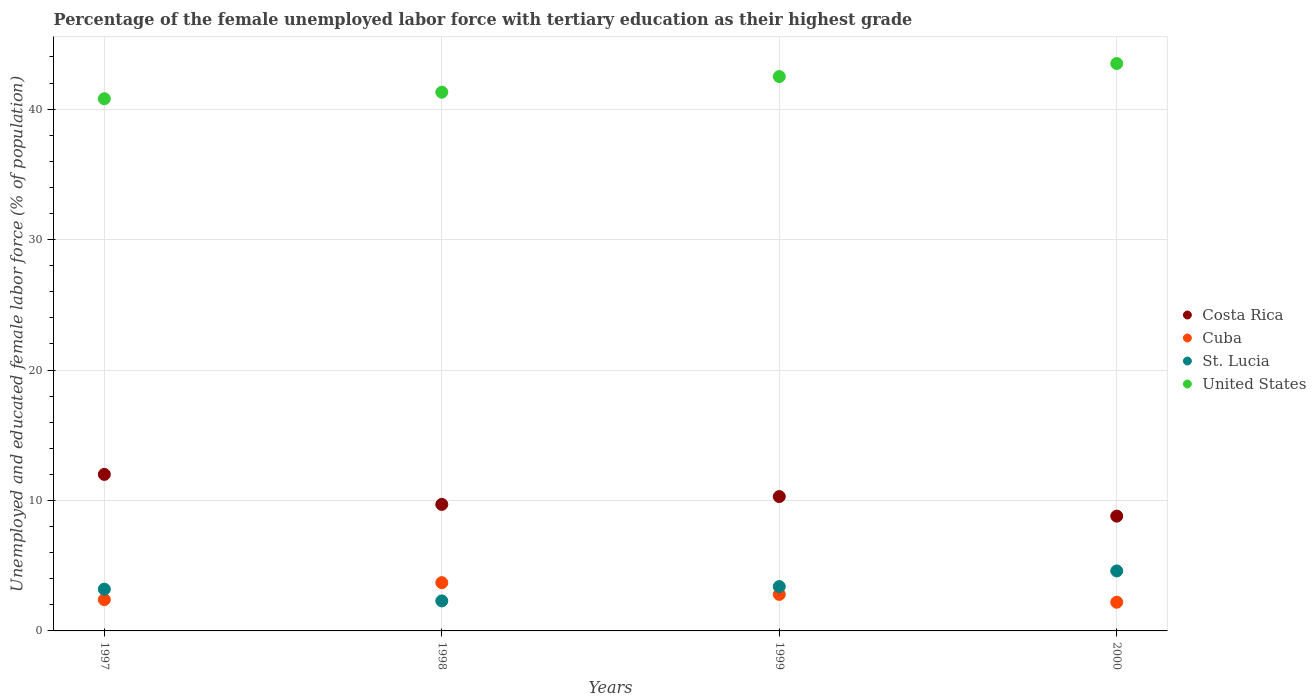What is the percentage of the unemployed female labor force with tertiary education in United States in 2000?
Offer a very short reply. 43.5. Across all years, what is the maximum percentage of the unemployed female labor force with tertiary education in Costa Rica?
Make the answer very short. 12. Across all years, what is the minimum percentage of the unemployed female labor force with tertiary education in Cuba?
Offer a very short reply. 2.2. In which year was the percentage of the unemployed female labor force with tertiary education in St. Lucia minimum?
Offer a terse response. 1998. What is the total percentage of the unemployed female labor force with tertiary education in Cuba in the graph?
Your answer should be very brief. 11.1. What is the difference between the percentage of the unemployed female labor force with tertiary education in United States in 1997 and that in 1999?
Provide a short and direct response. -1.7. What is the difference between the percentage of the unemployed female labor force with tertiary education in Cuba in 1997 and the percentage of the unemployed female labor force with tertiary education in United States in 2000?
Provide a succinct answer. -41.1. What is the average percentage of the unemployed female labor force with tertiary education in St. Lucia per year?
Provide a succinct answer. 3.38. In the year 1999, what is the difference between the percentage of the unemployed female labor force with tertiary education in Cuba and percentage of the unemployed female labor force with tertiary education in Costa Rica?
Provide a short and direct response. -7.5. In how many years, is the percentage of the unemployed female labor force with tertiary education in Costa Rica greater than 10 %?
Make the answer very short. 2. What is the ratio of the percentage of the unemployed female labor force with tertiary education in United States in 1998 to that in 1999?
Keep it short and to the point. 0.97. Is the percentage of the unemployed female labor force with tertiary education in Cuba in 1997 less than that in 2000?
Provide a succinct answer. No. What is the difference between the highest and the lowest percentage of the unemployed female labor force with tertiary education in St. Lucia?
Provide a succinct answer. 2.3. In how many years, is the percentage of the unemployed female labor force with tertiary education in St. Lucia greater than the average percentage of the unemployed female labor force with tertiary education in St. Lucia taken over all years?
Ensure brevity in your answer.  2. Is the sum of the percentage of the unemployed female labor force with tertiary education in Cuba in 1998 and 2000 greater than the maximum percentage of the unemployed female labor force with tertiary education in St. Lucia across all years?
Offer a very short reply. Yes. Is it the case that in every year, the sum of the percentage of the unemployed female labor force with tertiary education in Costa Rica and percentage of the unemployed female labor force with tertiary education in St. Lucia  is greater than the percentage of the unemployed female labor force with tertiary education in United States?
Provide a short and direct response. No. Is the percentage of the unemployed female labor force with tertiary education in United States strictly greater than the percentage of the unemployed female labor force with tertiary education in Cuba over the years?
Make the answer very short. Yes. Is the percentage of the unemployed female labor force with tertiary education in United States strictly less than the percentage of the unemployed female labor force with tertiary education in St. Lucia over the years?
Ensure brevity in your answer.  No. Are the values on the major ticks of Y-axis written in scientific E-notation?
Ensure brevity in your answer.  No. Does the graph contain grids?
Make the answer very short. Yes. What is the title of the graph?
Offer a very short reply. Percentage of the female unemployed labor force with tertiary education as their highest grade. What is the label or title of the Y-axis?
Ensure brevity in your answer.  Unemployed and educated female labor force (% of population). What is the Unemployed and educated female labor force (% of population) in Costa Rica in 1997?
Give a very brief answer. 12. What is the Unemployed and educated female labor force (% of population) of Cuba in 1997?
Keep it short and to the point. 2.4. What is the Unemployed and educated female labor force (% of population) in St. Lucia in 1997?
Make the answer very short. 3.2. What is the Unemployed and educated female labor force (% of population) of United States in 1997?
Keep it short and to the point. 40.8. What is the Unemployed and educated female labor force (% of population) of Costa Rica in 1998?
Make the answer very short. 9.7. What is the Unemployed and educated female labor force (% of population) in Cuba in 1998?
Ensure brevity in your answer.  3.7. What is the Unemployed and educated female labor force (% of population) in St. Lucia in 1998?
Provide a succinct answer. 2.3. What is the Unemployed and educated female labor force (% of population) in United States in 1998?
Ensure brevity in your answer.  41.3. What is the Unemployed and educated female labor force (% of population) in Costa Rica in 1999?
Offer a terse response. 10.3. What is the Unemployed and educated female labor force (% of population) of Cuba in 1999?
Ensure brevity in your answer.  2.8. What is the Unemployed and educated female labor force (% of population) of St. Lucia in 1999?
Offer a terse response. 3.4. What is the Unemployed and educated female labor force (% of population) in United States in 1999?
Keep it short and to the point. 42.5. What is the Unemployed and educated female labor force (% of population) in Costa Rica in 2000?
Provide a succinct answer. 8.8. What is the Unemployed and educated female labor force (% of population) in Cuba in 2000?
Your answer should be very brief. 2.2. What is the Unemployed and educated female labor force (% of population) in St. Lucia in 2000?
Ensure brevity in your answer.  4.6. What is the Unemployed and educated female labor force (% of population) of United States in 2000?
Ensure brevity in your answer.  43.5. Across all years, what is the maximum Unemployed and educated female labor force (% of population) of Cuba?
Give a very brief answer. 3.7. Across all years, what is the maximum Unemployed and educated female labor force (% of population) in St. Lucia?
Ensure brevity in your answer.  4.6. Across all years, what is the maximum Unemployed and educated female labor force (% of population) of United States?
Offer a terse response. 43.5. Across all years, what is the minimum Unemployed and educated female labor force (% of population) of Costa Rica?
Provide a succinct answer. 8.8. Across all years, what is the minimum Unemployed and educated female labor force (% of population) in Cuba?
Make the answer very short. 2.2. Across all years, what is the minimum Unemployed and educated female labor force (% of population) of St. Lucia?
Give a very brief answer. 2.3. Across all years, what is the minimum Unemployed and educated female labor force (% of population) in United States?
Offer a very short reply. 40.8. What is the total Unemployed and educated female labor force (% of population) in Costa Rica in the graph?
Offer a very short reply. 40.8. What is the total Unemployed and educated female labor force (% of population) in St. Lucia in the graph?
Your answer should be very brief. 13.5. What is the total Unemployed and educated female labor force (% of population) in United States in the graph?
Keep it short and to the point. 168.1. What is the difference between the Unemployed and educated female labor force (% of population) of Cuba in 1997 and that in 1998?
Offer a terse response. -1.3. What is the difference between the Unemployed and educated female labor force (% of population) of United States in 1997 and that in 1998?
Your response must be concise. -0.5. What is the difference between the Unemployed and educated female labor force (% of population) of United States in 1997 and that in 1999?
Make the answer very short. -1.7. What is the difference between the Unemployed and educated female labor force (% of population) of St. Lucia in 1997 and that in 2000?
Provide a succinct answer. -1.4. What is the difference between the Unemployed and educated female labor force (% of population) in United States in 1997 and that in 2000?
Your answer should be very brief. -2.7. What is the difference between the Unemployed and educated female labor force (% of population) in St. Lucia in 1998 and that in 1999?
Offer a very short reply. -1.1. What is the difference between the Unemployed and educated female labor force (% of population) in Costa Rica in 1998 and that in 2000?
Provide a short and direct response. 0.9. What is the difference between the Unemployed and educated female labor force (% of population) of St. Lucia in 1998 and that in 2000?
Offer a very short reply. -2.3. What is the difference between the Unemployed and educated female labor force (% of population) of United States in 1999 and that in 2000?
Make the answer very short. -1. What is the difference between the Unemployed and educated female labor force (% of population) of Costa Rica in 1997 and the Unemployed and educated female labor force (% of population) of Cuba in 1998?
Provide a short and direct response. 8.3. What is the difference between the Unemployed and educated female labor force (% of population) of Costa Rica in 1997 and the Unemployed and educated female labor force (% of population) of St. Lucia in 1998?
Make the answer very short. 9.7. What is the difference between the Unemployed and educated female labor force (% of population) in Costa Rica in 1997 and the Unemployed and educated female labor force (% of population) in United States in 1998?
Make the answer very short. -29.3. What is the difference between the Unemployed and educated female labor force (% of population) in Cuba in 1997 and the Unemployed and educated female labor force (% of population) in United States in 1998?
Your response must be concise. -38.9. What is the difference between the Unemployed and educated female labor force (% of population) in St. Lucia in 1997 and the Unemployed and educated female labor force (% of population) in United States in 1998?
Provide a short and direct response. -38.1. What is the difference between the Unemployed and educated female labor force (% of population) in Costa Rica in 1997 and the Unemployed and educated female labor force (% of population) in Cuba in 1999?
Provide a succinct answer. 9.2. What is the difference between the Unemployed and educated female labor force (% of population) of Costa Rica in 1997 and the Unemployed and educated female labor force (% of population) of United States in 1999?
Make the answer very short. -30.5. What is the difference between the Unemployed and educated female labor force (% of population) of Cuba in 1997 and the Unemployed and educated female labor force (% of population) of United States in 1999?
Keep it short and to the point. -40.1. What is the difference between the Unemployed and educated female labor force (% of population) of St. Lucia in 1997 and the Unemployed and educated female labor force (% of population) of United States in 1999?
Make the answer very short. -39.3. What is the difference between the Unemployed and educated female labor force (% of population) in Costa Rica in 1997 and the Unemployed and educated female labor force (% of population) in Cuba in 2000?
Offer a very short reply. 9.8. What is the difference between the Unemployed and educated female labor force (% of population) of Costa Rica in 1997 and the Unemployed and educated female labor force (% of population) of United States in 2000?
Provide a short and direct response. -31.5. What is the difference between the Unemployed and educated female labor force (% of population) of Cuba in 1997 and the Unemployed and educated female labor force (% of population) of United States in 2000?
Your response must be concise. -41.1. What is the difference between the Unemployed and educated female labor force (% of population) of St. Lucia in 1997 and the Unemployed and educated female labor force (% of population) of United States in 2000?
Keep it short and to the point. -40.3. What is the difference between the Unemployed and educated female labor force (% of population) of Costa Rica in 1998 and the Unemployed and educated female labor force (% of population) of Cuba in 1999?
Ensure brevity in your answer.  6.9. What is the difference between the Unemployed and educated female labor force (% of population) in Costa Rica in 1998 and the Unemployed and educated female labor force (% of population) in United States in 1999?
Provide a short and direct response. -32.8. What is the difference between the Unemployed and educated female labor force (% of population) in Cuba in 1998 and the Unemployed and educated female labor force (% of population) in St. Lucia in 1999?
Provide a short and direct response. 0.3. What is the difference between the Unemployed and educated female labor force (% of population) in Cuba in 1998 and the Unemployed and educated female labor force (% of population) in United States in 1999?
Your response must be concise. -38.8. What is the difference between the Unemployed and educated female labor force (% of population) in St. Lucia in 1998 and the Unemployed and educated female labor force (% of population) in United States in 1999?
Provide a short and direct response. -40.2. What is the difference between the Unemployed and educated female labor force (% of population) of Costa Rica in 1998 and the Unemployed and educated female labor force (% of population) of Cuba in 2000?
Give a very brief answer. 7.5. What is the difference between the Unemployed and educated female labor force (% of population) in Costa Rica in 1998 and the Unemployed and educated female labor force (% of population) in United States in 2000?
Provide a succinct answer. -33.8. What is the difference between the Unemployed and educated female labor force (% of population) in Cuba in 1998 and the Unemployed and educated female labor force (% of population) in St. Lucia in 2000?
Your response must be concise. -0.9. What is the difference between the Unemployed and educated female labor force (% of population) in Cuba in 1998 and the Unemployed and educated female labor force (% of population) in United States in 2000?
Keep it short and to the point. -39.8. What is the difference between the Unemployed and educated female labor force (% of population) of St. Lucia in 1998 and the Unemployed and educated female labor force (% of population) of United States in 2000?
Offer a very short reply. -41.2. What is the difference between the Unemployed and educated female labor force (% of population) of Costa Rica in 1999 and the Unemployed and educated female labor force (% of population) of Cuba in 2000?
Your answer should be compact. 8.1. What is the difference between the Unemployed and educated female labor force (% of population) of Costa Rica in 1999 and the Unemployed and educated female labor force (% of population) of St. Lucia in 2000?
Give a very brief answer. 5.7. What is the difference between the Unemployed and educated female labor force (% of population) of Costa Rica in 1999 and the Unemployed and educated female labor force (% of population) of United States in 2000?
Provide a short and direct response. -33.2. What is the difference between the Unemployed and educated female labor force (% of population) of Cuba in 1999 and the Unemployed and educated female labor force (% of population) of St. Lucia in 2000?
Offer a terse response. -1.8. What is the difference between the Unemployed and educated female labor force (% of population) of Cuba in 1999 and the Unemployed and educated female labor force (% of population) of United States in 2000?
Offer a terse response. -40.7. What is the difference between the Unemployed and educated female labor force (% of population) in St. Lucia in 1999 and the Unemployed and educated female labor force (% of population) in United States in 2000?
Make the answer very short. -40.1. What is the average Unemployed and educated female labor force (% of population) in Costa Rica per year?
Make the answer very short. 10.2. What is the average Unemployed and educated female labor force (% of population) in Cuba per year?
Offer a terse response. 2.77. What is the average Unemployed and educated female labor force (% of population) of St. Lucia per year?
Your response must be concise. 3.38. What is the average Unemployed and educated female labor force (% of population) in United States per year?
Your answer should be compact. 42.02. In the year 1997, what is the difference between the Unemployed and educated female labor force (% of population) of Costa Rica and Unemployed and educated female labor force (% of population) of United States?
Your answer should be very brief. -28.8. In the year 1997, what is the difference between the Unemployed and educated female labor force (% of population) of Cuba and Unemployed and educated female labor force (% of population) of United States?
Offer a terse response. -38.4. In the year 1997, what is the difference between the Unemployed and educated female labor force (% of population) of St. Lucia and Unemployed and educated female labor force (% of population) of United States?
Provide a short and direct response. -37.6. In the year 1998, what is the difference between the Unemployed and educated female labor force (% of population) of Costa Rica and Unemployed and educated female labor force (% of population) of Cuba?
Offer a terse response. 6. In the year 1998, what is the difference between the Unemployed and educated female labor force (% of population) of Costa Rica and Unemployed and educated female labor force (% of population) of United States?
Keep it short and to the point. -31.6. In the year 1998, what is the difference between the Unemployed and educated female labor force (% of population) of Cuba and Unemployed and educated female labor force (% of population) of St. Lucia?
Keep it short and to the point. 1.4. In the year 1998, what is the difference between the Unemployed and educated female labor force (% of population) of Cuba and Unemployed and educated female labor force (% of population) of United States?
Make the answer very short. -37.6. In the year 1998, what is the difference between the Unemployed and educated female labor force (% of population) of St. Lucia and Unemployed and educated female labor force (% of population) of United States?
Keep it short and to the point. -39. In the year 1999, what is the difference between the Unemployed and educated female labor force (% of population) of Costa Rica and Unemployed and educated female labor force (% of population) of Cuba?
Offer a terse response. 7.5. In the year 1999, what is the difference between the Unemployed and educated female labor force (% of population) in Costa Rica and Unemployed and educated female labor force (% of population) in St. Lucia?
Keep it short and to the point. 6.9. In the year 1999, what is the difference between the Unemployed and educated female labor force (% of population) of Costa Rica and Unemployed and educated female labor force (% of population) of United States?
Offer a terse response. -32.2. In the year 1999, what is the difference between the Unemployed and educated female labor force (% of population) in Cuba and Unemployed and educated female labor force (% of population) in United States?
Provide a short and direct response. -39.7. In the year 1999, what is the difference between the Unemployed and educated female labor force (% of population) of St. Lucia and Unemployed and educated female labor force (% of population) of United States?
Your answer should be very brief. -39.1. In the year 2000, what is the difference between the Unemployed and educated female labor force (% of population) in Costa Rica and Unemployed and educated female labor force (% of population) in Cuba?
Offer a very short reply. 6.6. In the year 2000, what is the difference between the Unemployed and educated female labor force (% of population) of Costa Rica and Unemployed and educated female labor force (% of population) of St. Lucia?
Your answer should be compact. 4.2. In the year 2000, what is the difference between the Unemployed and educated female labor force (% of population) in Costa Rica and Unemployed and educated female labor force (% of population) in United States?
Keep it short and to the point. -34.7. In the year 2000, what is the difference between the Unemployed and educated female labor force (% of population) of Cuba and Unemployed and educated female labor force (% of population) of United States?
Ensure brevity in your answer.  -41.3. In the year 2000, what is the difference between the Unemployed and educated female labor force (% of population) in St. Lucia and Unemployed and educated female labor force (% of population) in United States?
Your answer should be very brief. -38.9. What is the ratio of the Unemployed and educated female labor force (% of population) in Costa Rica in 1997 to that in 1998?
Give a very brief answer. 1.24. What is the ratio of the Unemployed and educated female labor force (% of population) of Cuba in 1997 to that in 1998?
Your answer should be very brief. 0.65. What is the ratio of the Unemployed and educated female labor force (% of population) in St. Lucia in 1997 to that in 1998?
Your answer should be compact. 1.39. What is the ratio of the Unemployed and educated female labor force (% of population) in United States in 1997 to that in 1998?
Provide a short and direct response. 0.99. What is the ratio of the Unemployed and educated female labor force (% of population) of Costa Rica in 1997 to that in 1999?
Offer a terse response. 1.17. What is the ratio of the Unemployed and educated female labor force (% of population) of Cuba in 1997 to that in 1999?
Make the answer very short. 0.86. What is the ratio of the Unemployed and educated female labor force (% of population) in United States in 1997 to that in 1999?
Provide a short and direct response. 0.96. What is the ratio of the Unemployed and educated female labor force (% of population) in Costa Rica in 1997 to that in 2000?
Make the answer very short. 1.36. What is the ratio of the Unemployed and educated female labor force (% of population) of Cuba in 1997 to that in 2000?
Give a very brief answer. 1.09. What is the ratio of the Unemployed and educated female labor force (% of population) in St. Lucia in 1997 to that in 2000?
Your answer should be compact. 0.7. What is the ratio of the Unemployed and educated female labor force (% of population) in United States in 1997 to that in 2000?
Your answer should be very brief. 0.94. What is the ratio of the Unemployed and educated female labor force (% of population) in Costa Rica in 1998 to that in 1999?
Your answer should be compact. 0.94. What is the ratio of the Unemployed and educated female labor force (% of population) of Cuba in 1998 to that in 1999?
Offer a very short reply. 1.32. What is the ratio of the Unemployed and educated female labor force (% of population) of St. Lucia in 1998 to that in 1999?
Offer a terse response. 0.68. What is the ratio of the Unemployed and educated female labor force (% of population) of United States in 1998 to that in 1999?
Make the answer very short. 0.97. What is the ratio of the Unemployed and educated female labor force (% of population) in Costa Rica in 1998 to that in 2000?
Provide a succinct answer. 1.1. What is the ratio of the Unemployed and educated female labor force (% of population) in Cuba in 1998 to that in 2000?
Make the answer very short. 1.68. What is the ratio of the Unemployed and educated female labor force (% of population) of St. Lucia in 1998 to that in 2000?
Provide a short and direct response. 0.5. What is the ratio of the Unemployed and educated female labor force (% of population) in United States in 1998 to that in 2000?
Ensure brevity in your answer.  0.95. What is the ratio of the Unemployed and educated female labor force (% of population) of Costa Rica in 1999 to that in 2000?
Your response must be concise. 1.17. What is the ratio of the Unemployed and educated female labor force (% of population) of Cuba in 1999 to that in 2000?
Make the answer very short. 1.27. What is the ratio of the Unemployed and educated female labor force (% of population) in St. Lucia in 1999 to that in 2000?
Your answer should be very brief. 0.74. What is the ratio of the Unemployed and educated female labor force (% of population) in United States in 1999 to that in 2000?
Make the answer very short. 0.98. What is the difference between the highest and the second highest Unemployed and educated female labor force (% of population) of Costa Rica?
Offer a terse response. 1.7. What is the difference between the highest and the second highest Unemployed and educated female labor force (% of population) in St. Lucia?
Your answer should be very brief. 1.2. What is the difference between the highest and the lowest Unemployed and educated female labor force (% of population) of Cuba?
Offer a terse response. 1.5. What is the difference between the highest and the lowest Unemployed and educated female labor force (% of population) of United States?
Offer a very short reply. 2.7. 